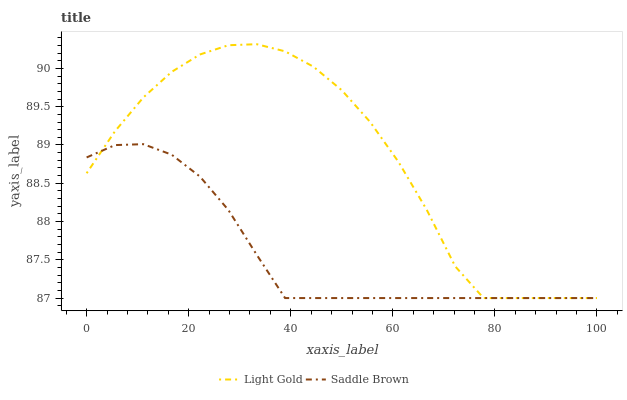Does Saddle Brown have the minimum area under the curve?
Answer yes or no. Yes. Does Light Gold have the maximum area under the curve?
Answer yes or no. Yes. Does Saddle Brown have the maximum area under the curve?
Answer yes or no. No. Is Saddle Brown the smoothest?
Answer yes or no. Yes. Is Light Gold the roughest?
Answer yes or no. Yes. Is Saddle Brown the roughest?
Answer yes or no. No. Does Light Gold have the lowest value?
Answer yes or no. Yes. Does Light Gold have the highest value?
Answer yes or no. Yes. Does Saddle Brown have the highest value?
Answer yes or no. No. Does Light Gold intersect Saddle Brown?
Answer yes or no. Yes. Is Light Gold less than Saddle Brown?
Answer yes or no. No. Is Light Gold greater than Saddle Brown?
Answer yes or no. No. 